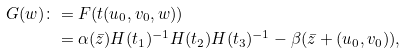Convert formula to latex. <formula><loc_0><loc_0><loc_500><loc_500>G ( w ) \colon & = F ( t ( u _ { 0 } , v _ { 0 } , w ) ) \\ & = \alpha ( \bar { z } ) H ( t _ { 1 } ) ^ { - 1 } H ( t _ { 2 } ) H ( t _ { 3 } ) ^ { - 1 } - \beta ( \bar { z } + ( u _ { 0 } , v _ { 0 } ) ) ,</formula> 